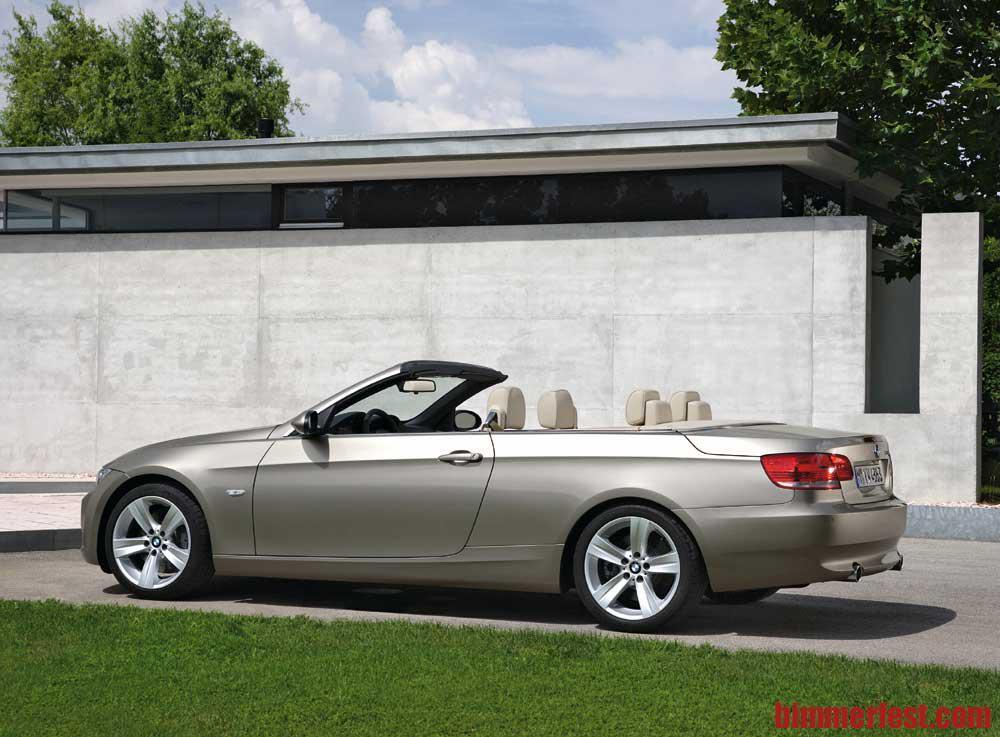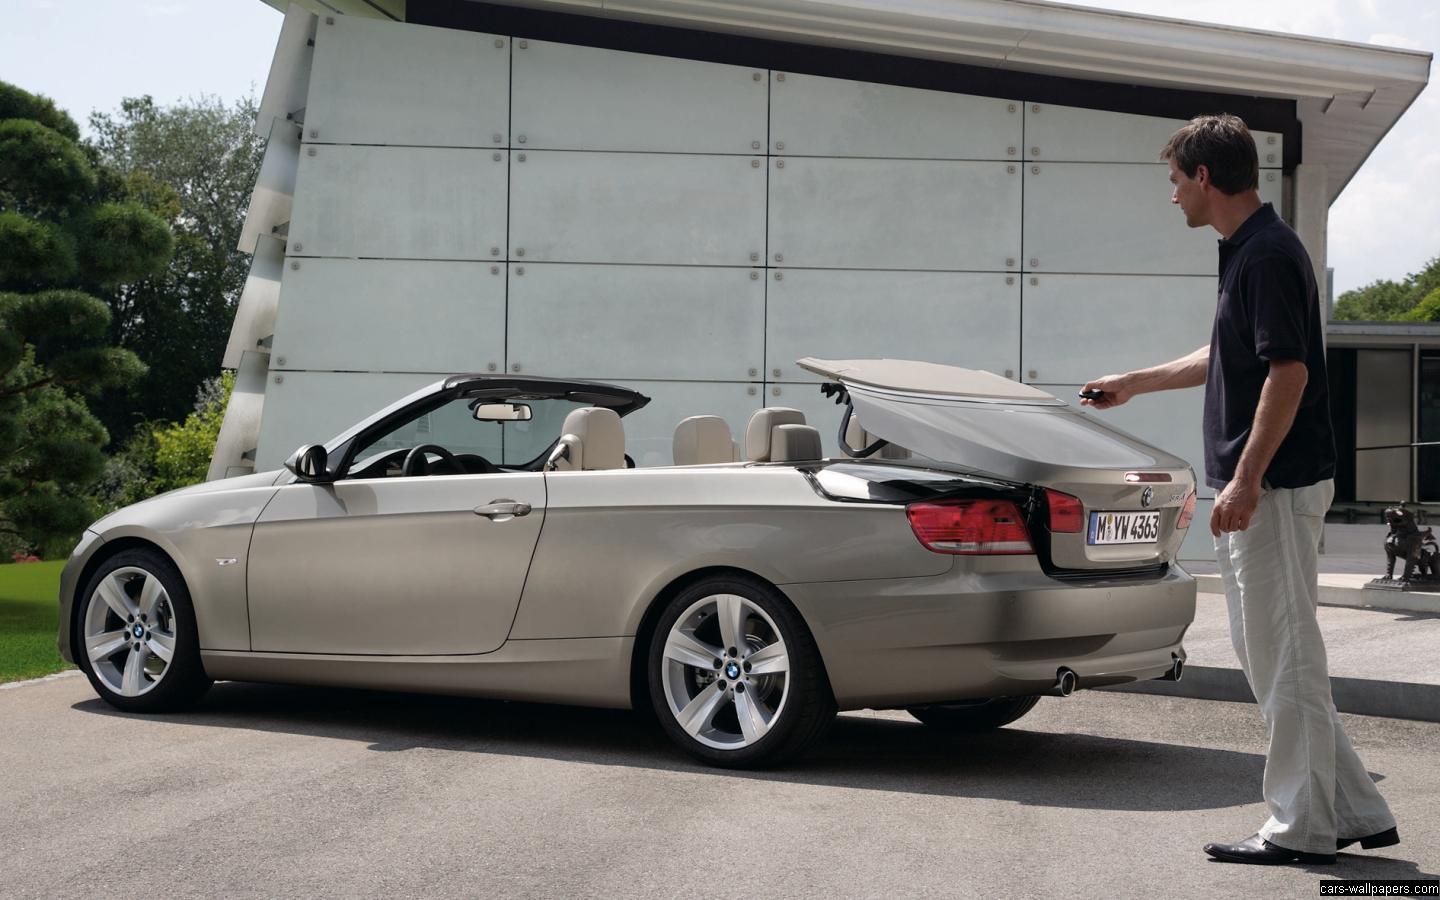The first image is the image on the left, the second image is the image on the right. For the images shown, is this caption "both pictures have convertibles in them" true? Answer yes or no. Yes. The first image is the image on the left, the second image is the image on the right. Given the left and right images, does the statement "there is a man standing next to a car in one of the images." hold true? Answer yes or no. Yes. 